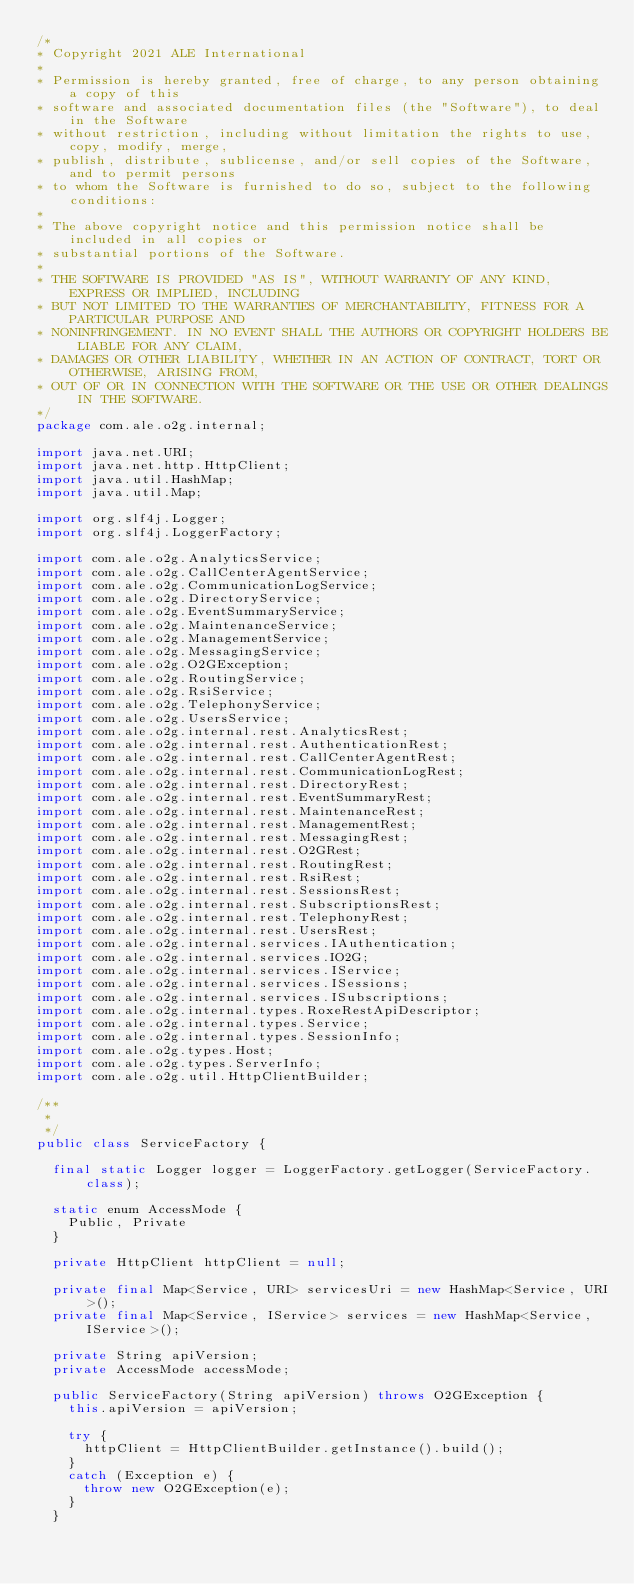<code> <loc_0><loc_0><loc_500><loc_500><_Java_>/*
* Copyright 2021 ALE International
*
* Permission is hereby granted, free of charge, to any person obtaining a copy of this 
* software and associated documentation files (the "Software"), to deal in the Software 
* without restriction, including without limitation the rights to use, copy, modify, merge, 
* publish, distribute, sublicense, and/or sell copies of the Software, and to permit persons 
* to whom the Software is furnished to do so, subject to the following conditions:
* 
* The above copyright notice and this permission notice shall be included in all copies or 
* substantial portions of the Software.
* 
* THE SOFTWARE IS PROVIDED "AS IS", WITHOUT WARRANTY OF ANY KIND, EXPRESS OR IMPLIED, INCLUDING 
* BUT NOT LIMITED TO THE WARRANTIES OF MERCHANTABILITY, FITNESS FOR A PARTICULAR PURPOSE AND 
* NONINFRINGEMENT. IN NO EVENT SHALL THE AUTHORS OR COPYRIGHT HOLDERS BE LIABLE FOR ANY CLAIM, 
* DAMAGES OR OTHER LIABILITY, WHETHER IN AN ACTION OF CONTRACT, TORT OR OTHERWISE, ARISING FROM, 
* OUT OF OR IN CONNECTION WITH THE SOFTWARE OR THE USE OR OTHER DEALINGS IN THE SOFTWARE.
*/
package com.ale.o2g.internal;

import java.net.URI;
import java.net.http.HttpClient;
import java.util.HashMap;
import java.util.Map;

import org.slf4j.Logger;
import org.slf4j.LoggerFactory;

import com.ale.o2g.AnalyticsService;
import com.ale.o2g.CallCenterAgentService;
import com.ale.o2g.CommunicationLogService;
import com.ale.o2g.DirectoryService;
import com.ale.o2g.EventSummaryService;
import com.ale.o2g.MaintenanceService;
import com.ale.o2g.ManagementService;
import com.ale.o2g.MessagingService;
import com.ale.o2g.O2GException;
import com.ale.o2g.RoutingService;
import com.ale.o2g.RsiService;
import com.ale.o2g.TelephonyService;
import com.ale.o2g.UsersService;
import com.ale.o2g.internal.rest.AnalyticsRest;
import com.ale.o2g.internal.rest.AuthenticationRest;
import com.ale.o2g.internal.rest.CallCenterAgentRest;
import com.ale.o2g.internal.rest.CommunicationLogRest;
import com.ale.o2g.internal.rest.DirectoryRest;
import com.ale.o2g.internal.rest.EventSummaryRest;
import com.ale.o2g.internal.rest.MaintenanceRest;
import com.ale.o2g.internal.rest.ManagementRest;
import com.ale.o2g.internal.rest.MessagingRest;
import com.ale.o2g.internal.rest.O2GRest;
import com.ale.o2g.internal.rest.RoutingRest;
import com.ale.o2g.internal.rest.RsiRest;
import com.ale.o2g.internal.rest.SessionsRest;
import com.ale.o2g.internal.rest.SubscriptionsRest;
import com.ale.o2g.internal.rest.TelephonyRest;
import com.ale.o2g.internal.rest.UsersRest;
import com.ale.o2g.internal.services.IAuthentication;
import com.ale.o2g.internal.services.IO2G;
import com.ale.o2g.internal.services.IService;
import com.ale.o2g.internal.services.ISessions;
import com.ale.o2g.internal.services.ISubscriptions;
import com.ale.o2g.internal.types.RoxeRestApiDescriptor;
import com.ale.o2g.internal.types.Service;
import com.ale.o2g.internal.types.SessionInfo;
import com.ale.o2g.types.Host;
import com.ale.o2g.types.ServerInfo;
import com.ale.o2g.util.HttpClientBuilder;

/**
 *
 */
public class ServiceFactory {

	final static Logger logger = LoggerFactory.getLogger(ServiceFactory.class);

	static enum AccessMode {
		Public, Private
	}

	private HttpClient httpClient = null;

	private final Map<Service, URI> servicesUri = new HashMap<Service, URI>();
	private final Map<Service, IService> services = new HashMap<Service, IService>();

	private String apiVersion;
	private AccessMode accessMode;

	public ServiceFactory(String apiVersion) throws O2GException {
		this.apiVersion = apiVersion;

		try {
			httpClient = HttpClientBuilder.getInstance().build();
		}
		catch (Exception e) {
			throw new O2GException(e);
		}
	}
</code> 